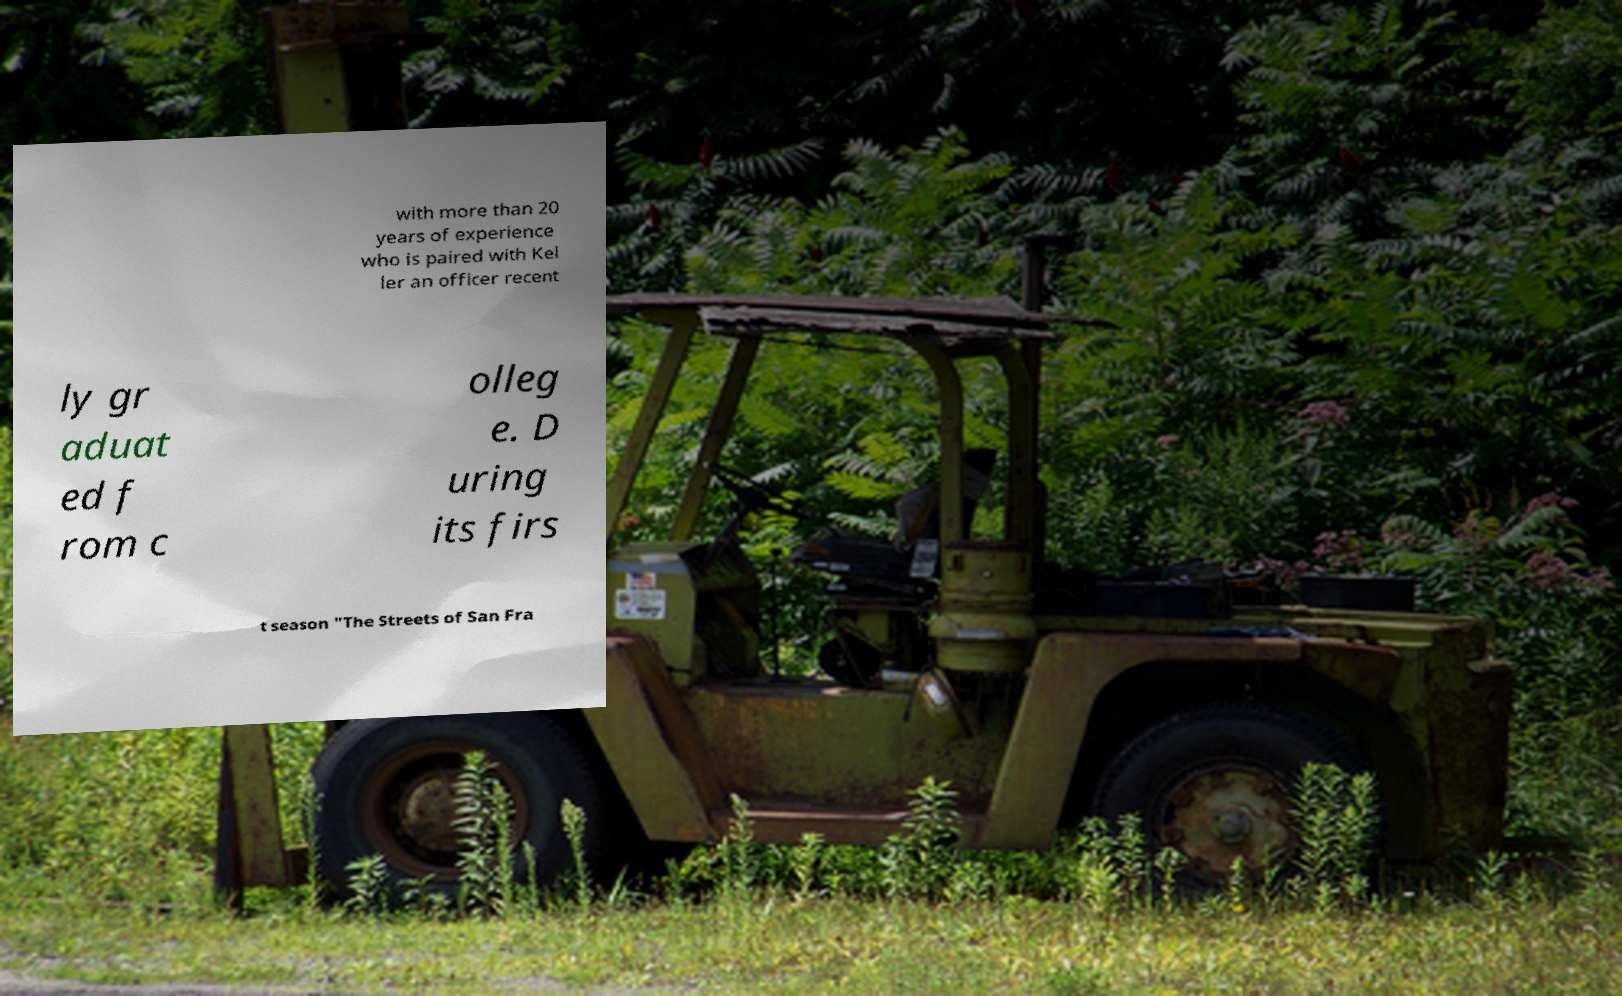Could you extract and type out the text from this image? with more than 20 years of experience who is paired with Kel ler an officer recent ly gr aduat ed f rom c olleg e. D uring its firs t season "The Streets of San Fra 